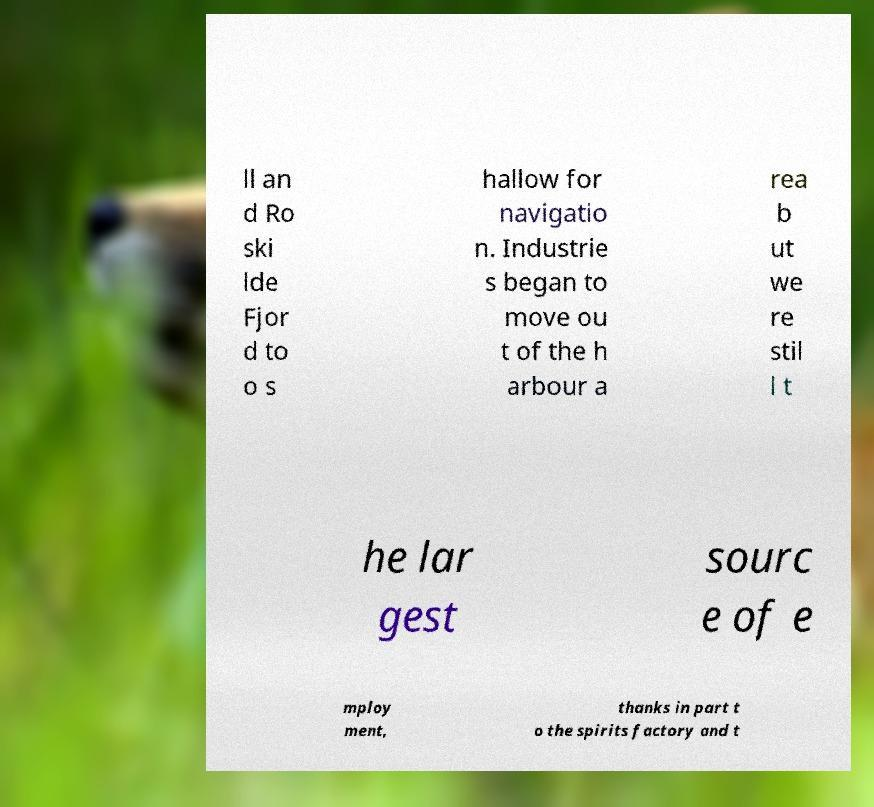Could you assist in decoding the text presented in this image and type it out clearly? ll an d Ro ski lde Fjor d to o s hallow for navigatio n. Industrie s began to move ou t of the h arbour a rea b ut we re stil l t he lar gest sourc e of e mploy ment, thanks in part t o the spirits factory and t 